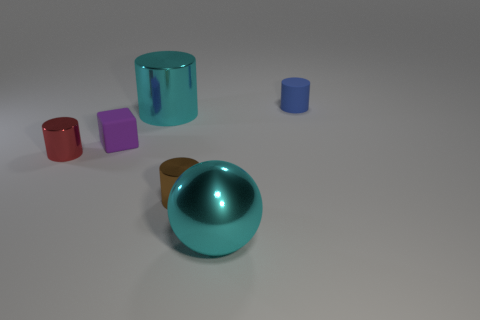There is a small shiny thing left of the rubber thing that is to the left of the tiny matte object that is to the right of the large sphere; what shape is it?
Give a very brief answer. Cylinder. There is a object that is both to the right of the cyan cylinder and behind the purple matte thing; what is its material?
Keep it short and to the point. Rubber. The object behind the big shiny object that is behind the tiny matte thing in front of the tiny blue cylinder is what color?
Offer a terse response. Blue. What number of cyan objects are small cylinders or large things?
Provide a short and direct response. 2. What number of other things are there of the same size as the purple thing?
Make the answer very short. 3. How many small metal blocks are there?
Provide a short and direct response. 0. Are there any other things that have the same shape as the purple rubber thing?
Give a very brief answer. No. Do the small cylinder that is on the right side of the metallic sphere and the cyan object that is behind the brown metal cylinder have the same material?
Your answer should be very brief. No. What is the tiny purple object made of?
Ensure brevity in your answer.  Rubber. What number of blue cylinders have the same material as the red cylinder?
Ensure brevity in your answer.  0. 